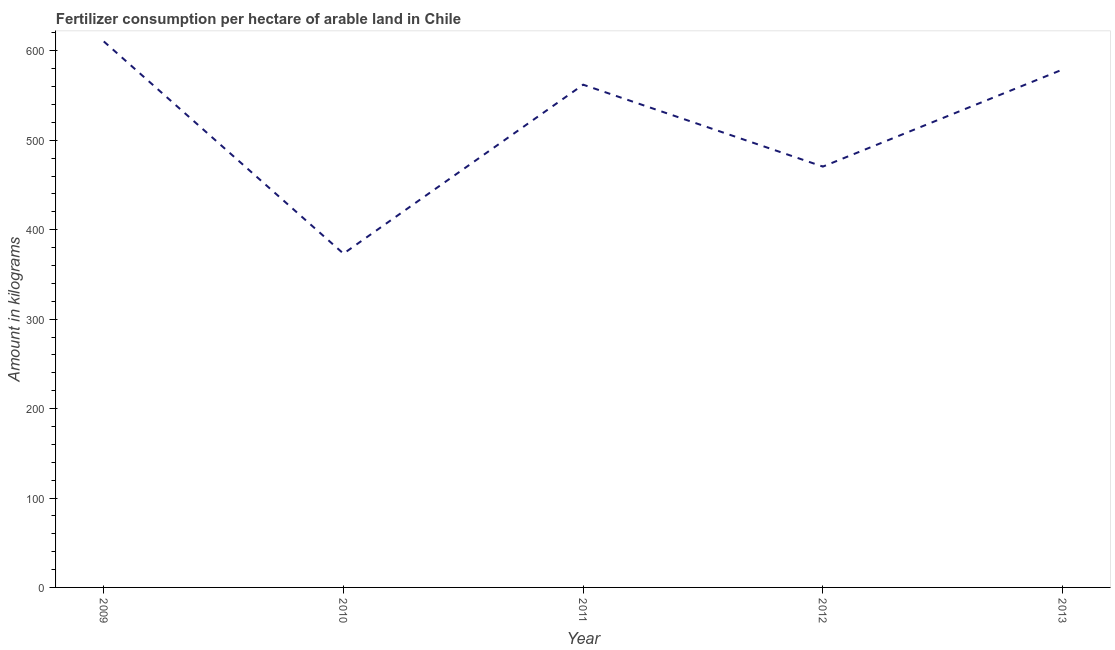What is the amount of fertilizer consumption in 2012?
Provide a succinct answer. 470.59. Across all years, what is the maximum amount of fertilizer consumption?
Provide a succinct answer. 610.55. Across all years, what is the minimum amount of fertilizer consumption?
Ensure brevity in your answer.  373.25. In which year was the amount of fertilizer consumption maximum?
Offer a very short reply. 2009. In which year was the amount of fertilizer consumption minimum?
Provide a short and direct response. 2010. What is the sum of the amount of fertilizer consumption?
Offer a very short reply. 2595.71. What is the difference between the amount of fertilizer consumption in 2009 and 2011?
Provide a succinct answer. 48.36. What is the average amount of fertilizer consumption per year?
Offer a very short reply. 519.14. What is the median amount of fertilizer consumption?
Offer a very short reply. 562.19. Do a majority of the years between 2013 and 2012 (inclusive) have amount of fertilizer consumption greater than 60 kg?
Provide a short and direct response. No. What is the ratio of the amount of fertilizer consumption in 2009 to that in 2012?
Provide a succinct answer. 1.3. Is the amount of fertilizer consumption in 2010 less than that in 2011?
Ensure brevity in your answer.  Yes. Is the difference between the amount of fertilizer consumption in 2009 and 2010 greater than the difference between any two years?
Provide a short and direct response. Yes. What is the difference between the highest and the second highest amount of fertilizer consumption?
Provide a short and direct response. 31.42. Is the sum of the amount of fertilizer consumption in 2011 and 2012 greater than the maximum amount of fertilizer consumption across all years?
Your answer should be very brief. Yes. What is the difference between the highest and the lowest amount of fertilizer consumption?
Make the answer very short. 237.3. How many lines are there?
Ensure brevity in your answer.  1. Does the graph contain any zero values?
Keep it short and to the point. No. What is the title of the graph?
Offer a very short reply. Fertilizer consumption per hectare of arable land in Chile . What is the label or title of the Y-axis?
Offer a very short reply. Amount in kilograms. What is the Amount in kilograms in 2009?
Your answer should be very brief. 610.55. What is the Amount in kilograms of 2010?
Your response must be concise. 373.25. What is the Amount in kilograms of 2011?
Offer a terse response. 562.19. What is the Amount in kilograms in 2012?
Keep it short and to the point. 470.59. What is the Amount in kilograms of 2013?
Give a very brief answer. 579.13. What is the difference between the Amount in kilograms in 2009 and 2010?
Give a very brief answer. 237.3. What is the difference between the Amount in kilograms in 2009 and 2011?
Give a very brief answer. 48.36. What is the difference between the Amount in kilograms in 2009 and 2012?
Your answer should be very brief. 139.97. What is the difference between the Amount in kilograms in 2009 and 2013?
Offer a very short reply. 31.42. What is the difference between the Amount in kilograms in 2010 and 2011?
Your answer should be compact. -188.94. What is the difference between the Amount in kilograms in 2010 and 2012?
Make the answer very short. -97.34. What is the difference between the Amount in kilograms in 2010 and 2013?
Provide a succinct answer. -205.88. What is the difference between the Amount in kilograms in 2011 and 2012?
Make the answer very short. 91.6. What is the difference between the Amount in kilograms in 2011 and 2013?
Keep it short and to the point. -16.94. What is the difference between the Amount in kilograms in 2012 and 2013?
Make the answer very short. -108.54. What is the ratio of the Amount in kilograms in 2009 to that in 2010?
Keep it short and to the point. 1.64. What is the ratio of the Amount in kilograms in 2009 to that in 2011?
Offer a terse response. 1.09. What is the ratio of the Amount in kilograms in 2009 to that in 2012?
Ensure brevity in your answer.  1.3. What is the ratio of the Amount in kilograms in 2009 to that in 2013?
Provide a succinct answer. 1.05. What is the ratio of the Amount in kilograms in 2010 to that in 2011?
Make the answer very short. 0.66. What is the ratio of the Amount in kilograms in 2010 to that in 2012?
Keep it short and to the point. 0.79. What is the ratio of the Amount in kilograms in 2010 to that in 2013?
Your answer should be very brief. 0.64. What is the ratio of the Amount in kilograms in 2011 to that in 2012?
Make the answer very short. 1.2. What is the ratio of the Amount in kilograms in 2012 to that in 2013?
Offer a very short reply. 0.81. 